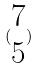Convert formula to latex. <formula><loc_0><loc_0><loc_500><loc_500>( \begin{matrix} 7 \\ 5 \end{matrix} )</formula> 